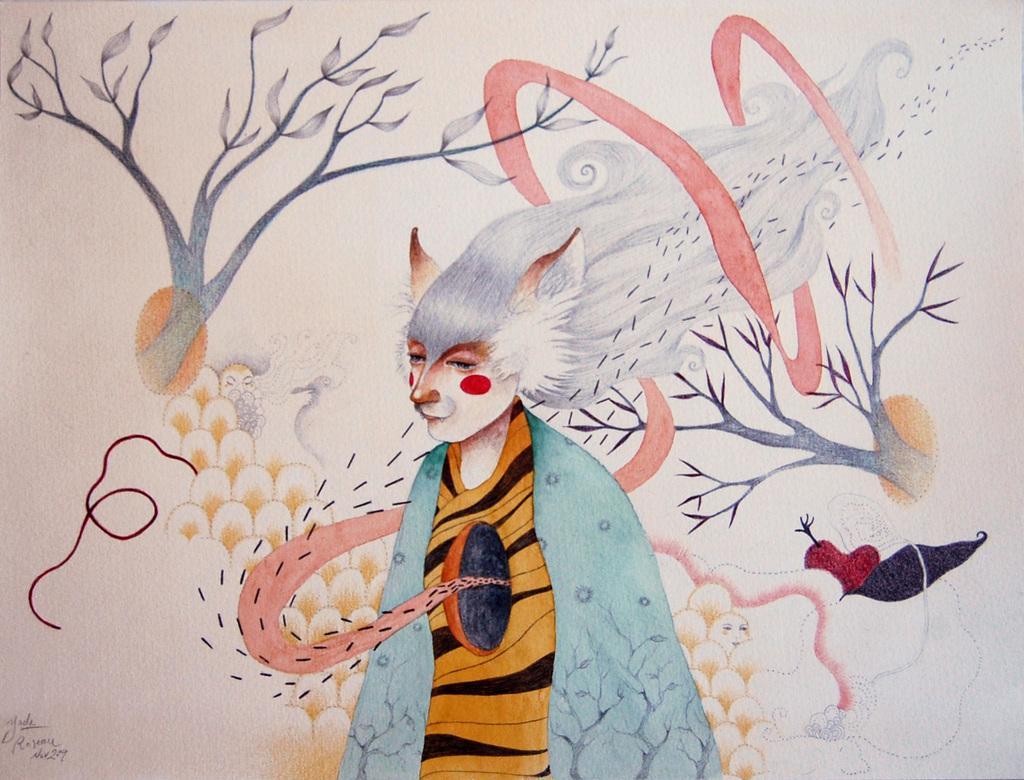How would you summarize this image in a sentence or two? In this picture we can see the branches, leaves, some objects, watermark and an animated image of a person. 